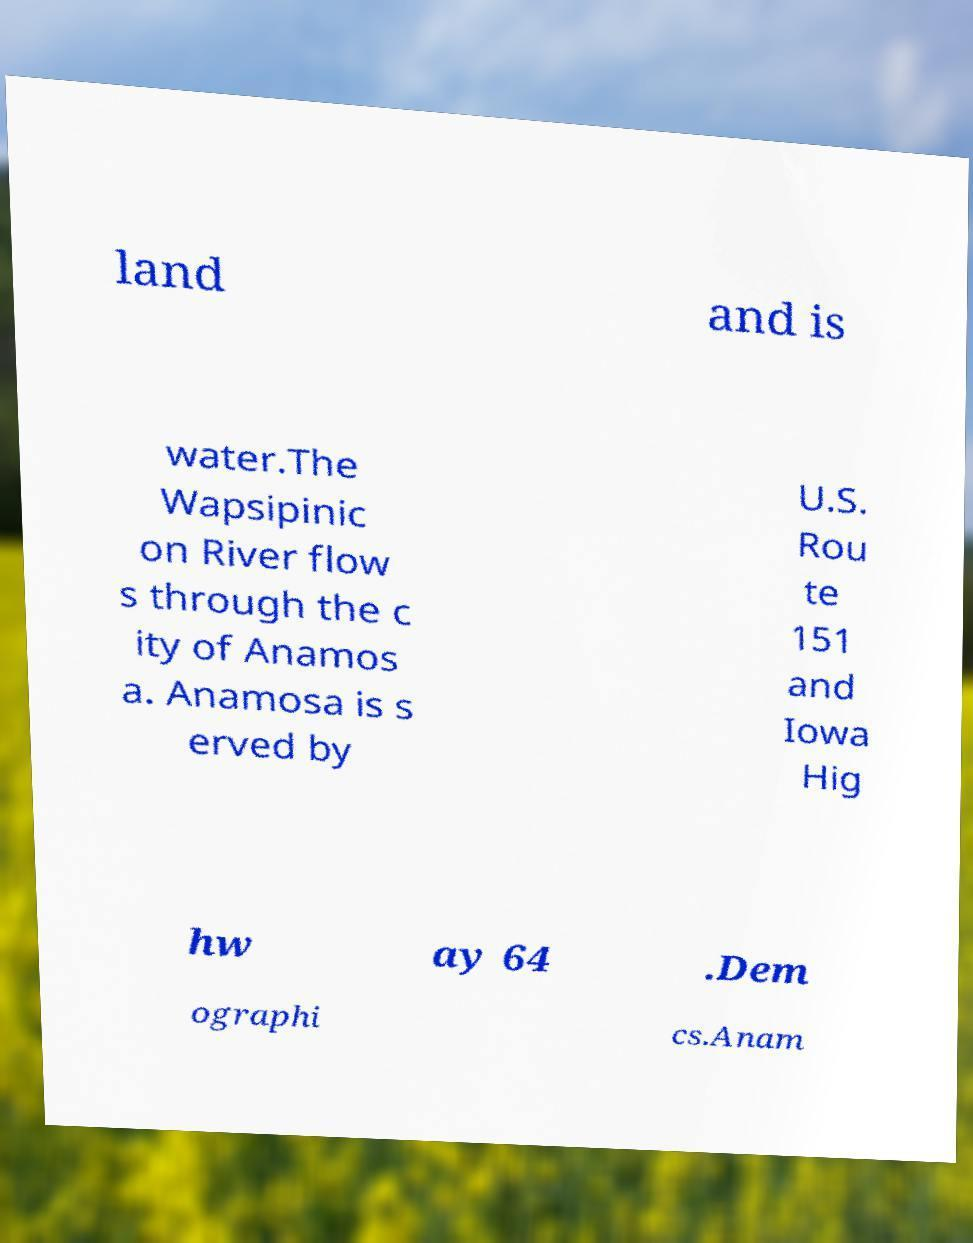Please read and relay the text visible in this image. What does it say? land and is water.The Wapsipinic on River flow s through the c ity of Anamos a. Anamosa is s erved by U.S. Rou te 151 and Iowa Hig hw ay 64 .Dem ographi cs.Anam 